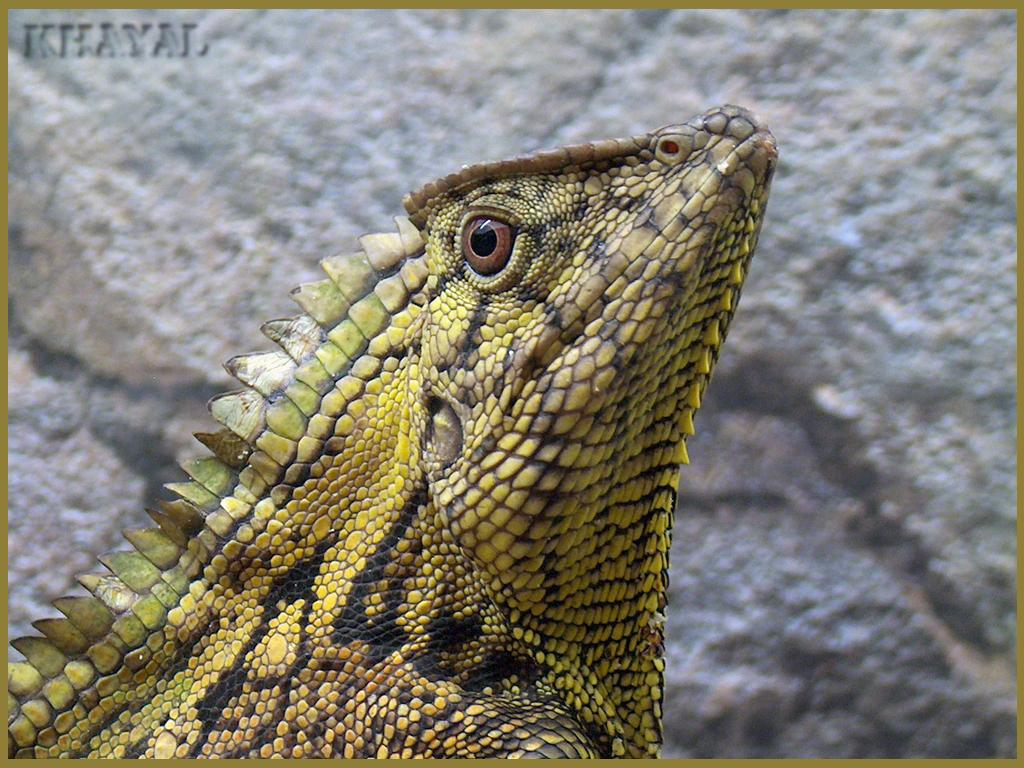What is the main subject in the front of the image? There is a lizard in the front of the image. How would you describe the background of the image? The background of the image is blurry. Can you identify any additional features in the image? There is a watermark at the top left side of the image. How does the lizard interact with the mom in the image? There is no mom present in the image, so the lizard cannot interact with a mom. 